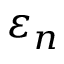<formula> <loc_0><loc_0><loc_500><loc_500>\varepsilon _ { n }</formula> 